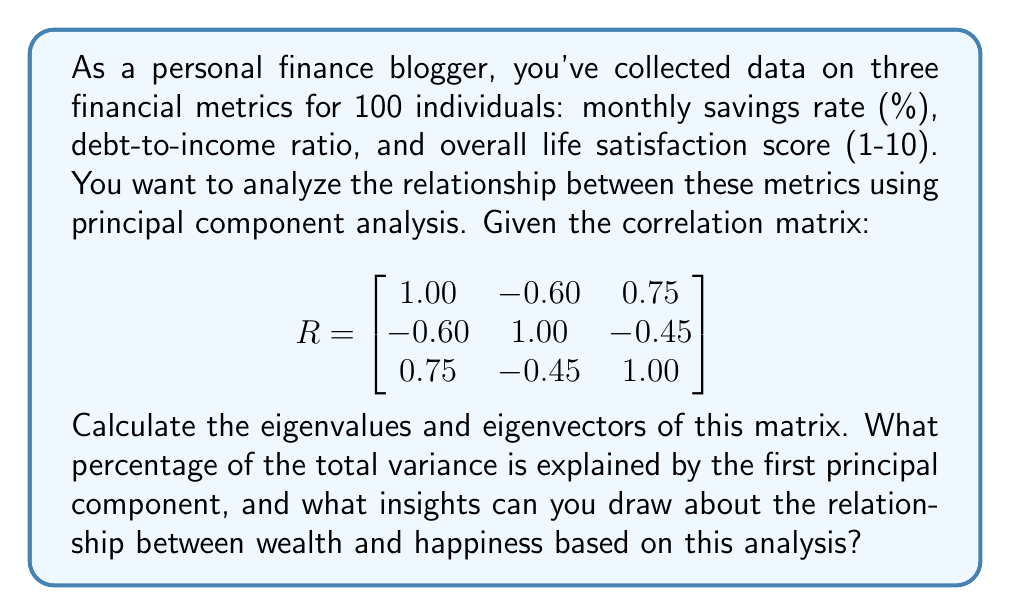Give your solution to this math problem. To solve this problem, we'll follow these steps:

1) First, we need to find the eigenvalues of the correlation matrix R. The characteristic equation is:

   $$det(R - \lambda I) = 0$$

   Expanding this:

   $$\begin{vmatrix}
   1-\lambda & -0.60 & 0.75 \\
   -0.60 & 1-\lambda & -0.45 \\
   0.75 & -0.45 & 1-\lambda
   \end{vmatrix} = 0$$

2) Solving this equation (which is cubic and can be solved using various methods), we get the eigenvalues:

   $$\lambda_1 \approx 2.1815, \lambda_2 \approx 0.7093, \lambda_3 \approx 0.1092$$

3) Now, we need to find the eigenvectors for each eigenvalue. For $\lambda_1$:

   $$(R - 2.1815I)\mathbf{v_1} = \mathbf{0}$$

   Solving this system of equations, we get (after normalization):

   $$\mathbf{v_1} \approx [0.6164, -0.4619, 0.6376]^T$$

4) Similarly, for $\lambda_2$ and $\lambda_3$, we get:

   $$\mathbf{v_2} \approx [-0.0726, -0.8762, -0.4765]^T$$
   $$\mathbf{v_3} \approx [0.7841, 0.1381, -0.6051]^T$$

5) The percentage of variance explained by the first principal component is:

   $$\frac{\lambda_1}{\lambda_1 + \lambda_2 + \lambda_3} \times 100\% \approx 72.72\%$$

6) Interpreting the results:
   - The first principal component explains a large portion of the variance (72.72%), indicating a strong relationship between the variables.
   - The eigenvector for the first principal component shows positive weights for savings rate and life satisfaction, and a negative weight for debt-to-income ratio.
   - This suggests that higher savings rates and lower debt-to-income ratios are associated with higher life satisfaction scores.

These findings support the idea that financial health (higher savings, lower debt) is positively correlated with happiness, but it's not a perfect relationship as other factors also contribute to life satisfaction.
Answer: 72.72% variance explained by first principal component; positive correlation between financial health and happiness. 